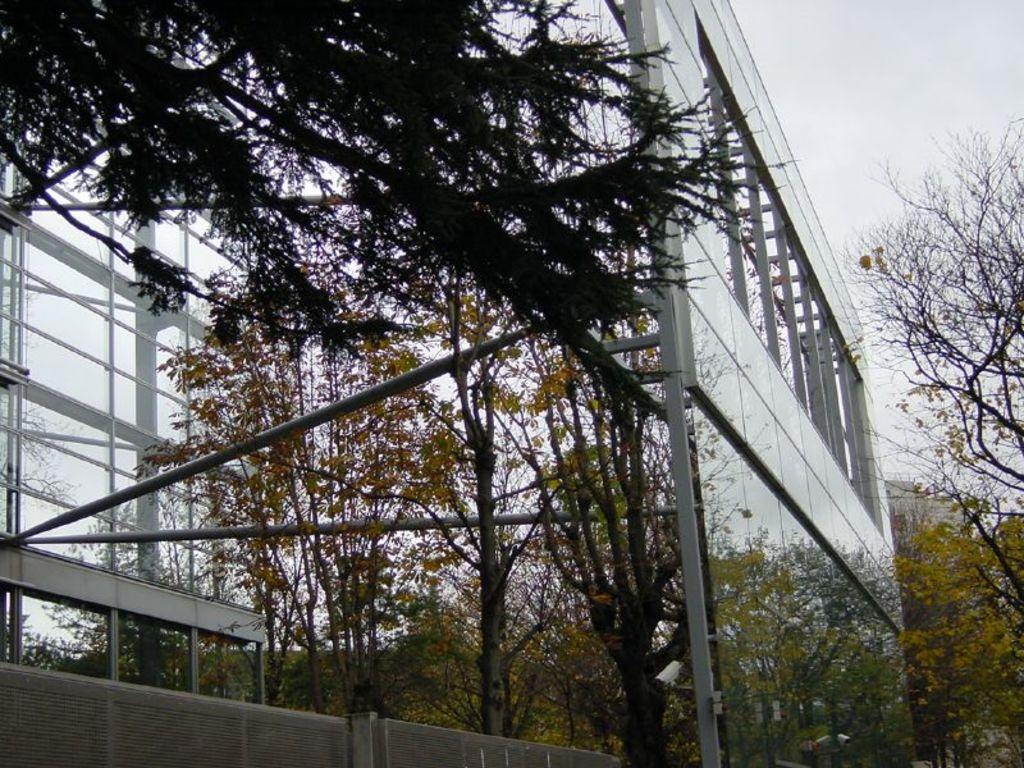What type of wall is present in the image? There is a glass wall with poles in the image. What is attached to the poles? Some objects are attached to the poles. What can be seen in the background of the image? There are trees visible in the image. What type of barrier is present in the image? There is fencing in the image. What is visible at the top of the image? The sky is visible in the image. What type of sock is hanging on the pole in the image? There is no sock present in the image; it features a glass wall with poles and objects attached to them. What type of meal is being prepared on the plate in the image? There is no plate or meal present in the image. 